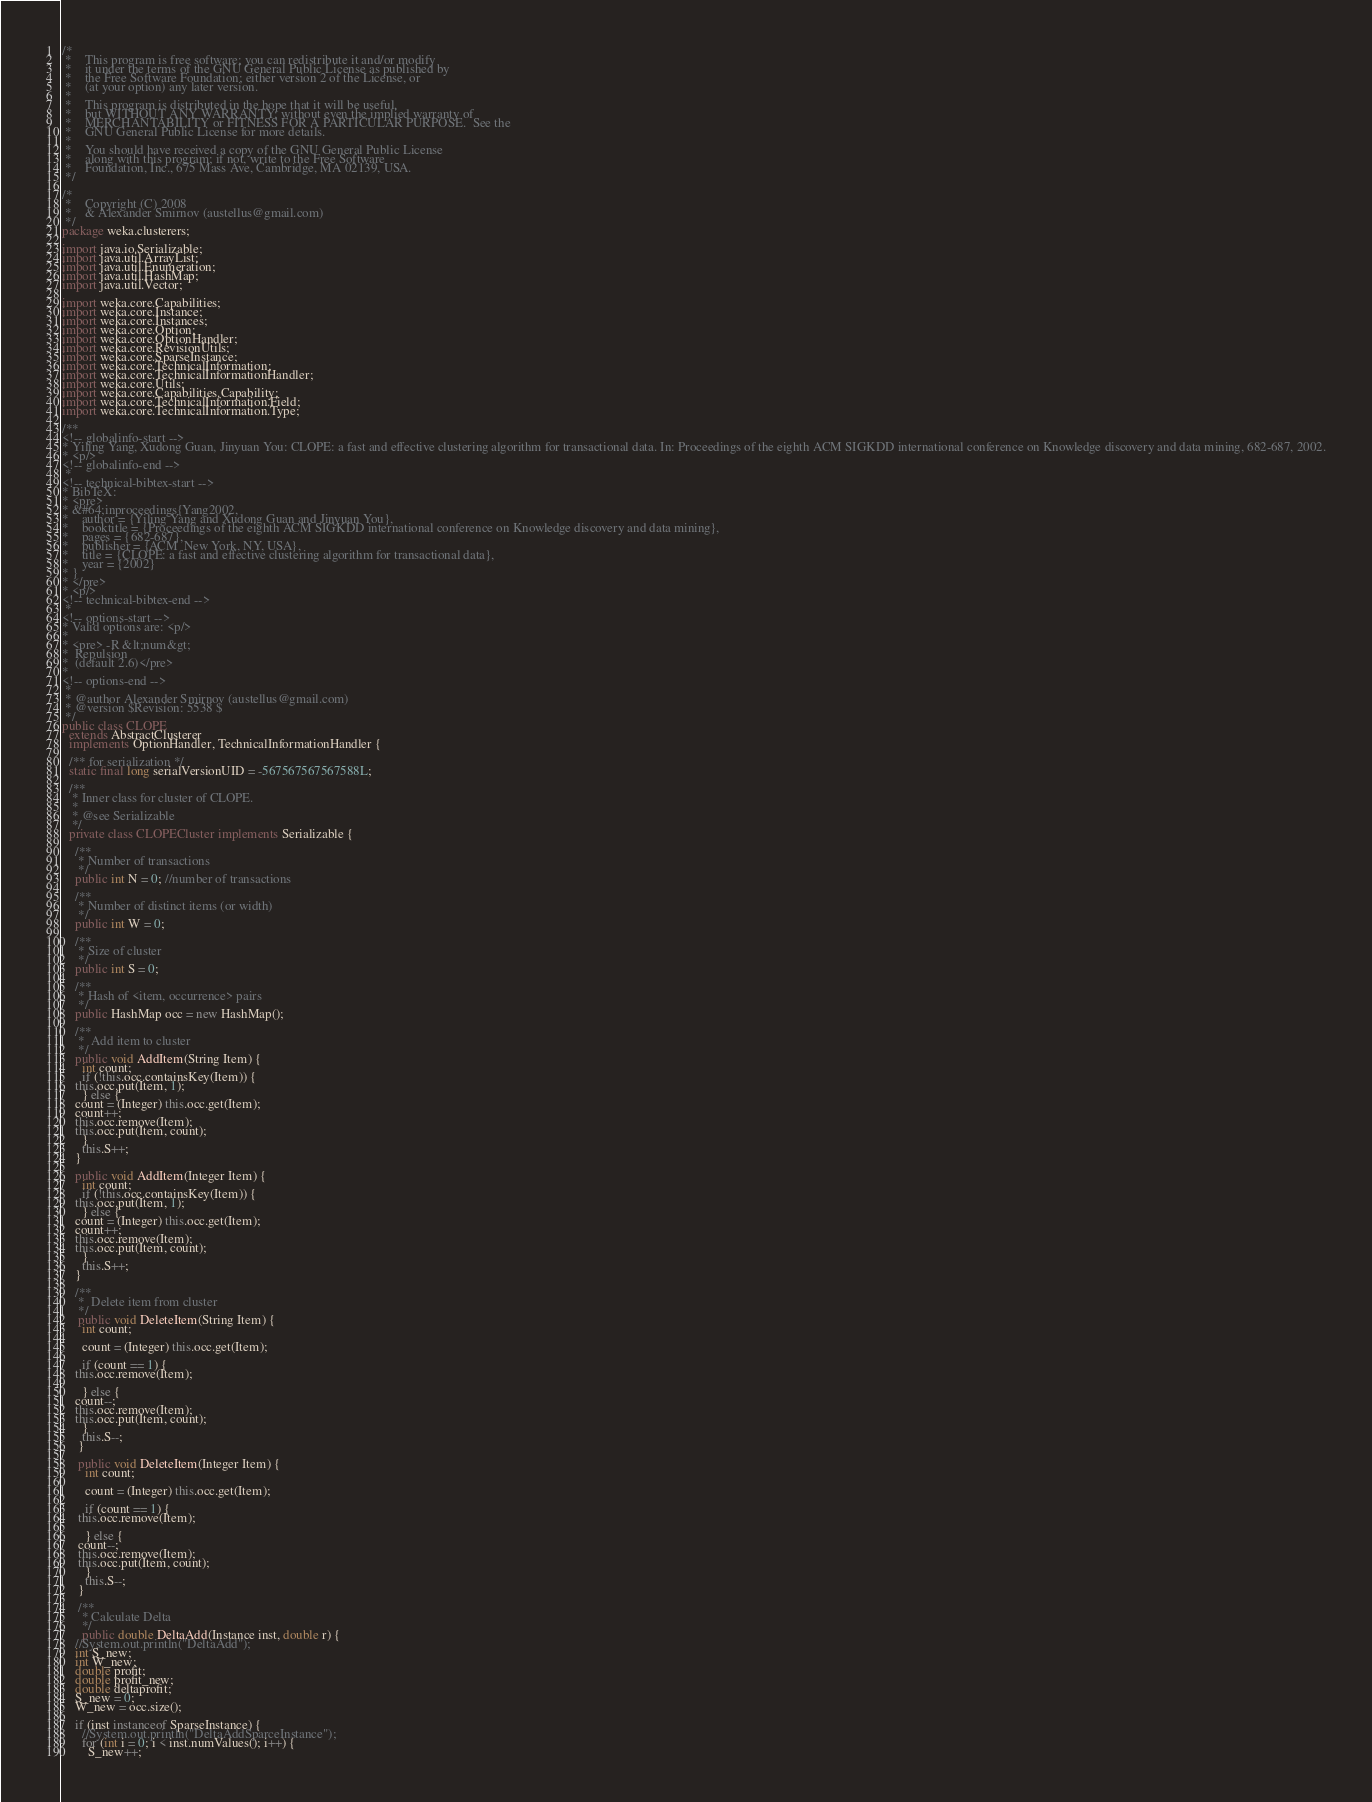<code> <loc_0><loc_0><loc_500><loc_500><_Java_>/*
 *    This program is free software; you can redistribute it and/or modify
 *    it under the terms of the GNU General Public License as published by
 *    the Free Software Foundation; either version 2 of the License, or
 *    (at your option) any later version.
 *
 *    This program is distributed in the hope that it will be useful,
 *    but WITHOUT ANY WARRANTY; without even the implied warranty of
 *    MERCHANTABILITY or FITNESS FOR A PARTICULAR PURPOSE.  See the
 *    GNU General Public License for more details.
 *
 *    You should have received a copy of the GNU General Public License
 *    along with this program; if not, write to the Free Software
 *    Foundation, Inc., 675 Mass Ave, Cambridge, MA 02139, USA.
 */

/*
 *    Copyright (C) 2008
 *    & Alexander Smirnov (austellus@gmail.com)
 */
package weka.clusterers;

import java.io.Serializable;
import java.util.ArrayList;
import java.util.Enumeration;
import java.util.HashMap;
import java.util.Vector;

import weka.core.Capabilities;
import weka.core.Instance;
import weka.core.Instances;
import weka.core.Option;
import weka.core.OptionHandler;
import weka.core.RevisionUtils;
import weka.core.SparseInstance;
import weka.core.TechnicalInformation;
import weka.core.TechnicalInformationHandler;
import weka.core.Utils;
import weka.core.Capabilities.Capability;
import weka.core.TechnicalInformation.Field;
import weka.core.TechnicalInformation.Type;

/**
<!-- globalinfo-start -->
* Yiling Yang, Xudong Guan, Jinyuan You: CLOPE: a fast and effective clustering algorithm for transactional data. In: Proceedings of the eighth ACM SIGKDD international conference on Knowledge discovery and data mining, 682-687, 2002.
* <p/>
<!-- globalinfo-end -->
 *
<!-- technical-bibtex-start -->
* BibTeX:
* <pre>
* &#64;inproceedings{Yang2002,
*    author = {Yiling Yang and Xudong Guan and Jinyuan You},
*    booktitle = {Proceedings of the eighth ACM SIGKDD international conference on Knowledge discovery and data mining},
*    pages = {682-687},
*    publisher = {ACM  New York, NY, USA},
*    title = {CLOPE: a fast and effective clustering algorithm for transactional data},
*    year = {2002}
* }
* </pre>
* <p/>
<!-- technical-bibtex-end -->
 *
<!-- options-start -->
* Valid options are: <p/>
* 
* <pre> -R &lt;num&gt;
*  Repulsion
*  (default 2.6)</pre>
* 
<!-- options-end -->
 *
 * @author Alexander Smirnov (austellus@gmail.com)
 * @version $Revision: 5538 $
 */
public class CLOPE
  extends AbstractClusterer
  implements OptionHandler, TechnicalInformationHandler {

  /** for serialization */
  static final long serialVersionUID = -567567567567588L;

  /**
   * Inner class for cluster of CLOPE.
   *
   * @see Serializable
   */
  private class CLOPECluster implements Serializable {

    /**
     * Number of transactions
     */
    public int N = 0; //number of transactions
    
    /**
     * Number of distinct items (or width)
     */
    public int W = 0;
    
    /**
     * Size of cluster
     */
    public int S = 0;
    
    /**
     * Hash of <item, occurrence> pairs
     */
    public HashMap occ = new HashMap();

    /**
     *  Add item to cluster
     */
    public void AddItem(String Item) {
      int count;
      if (!this.occ.containsKey(Item)) {
	this.occ.put(Item, 1);
      } else {
	count = (Integer) this.occ.get(Item);
	count++;
	this.occ.remove(Item);
	this.occ.put(Item, count);
      }
      this.S++;
    }

    public void AddItem(Integer Item) {
      int count;
      if (!this.occ.containsKey(Item)) {
	this.occ.put(Item, 1);
      } else {
	count = (Integer) this.occ.get(Item);
	count++;
	this.occ.remove(Item);
	this.occ.put(Item, count);
      }
      this.S++;
    }

    /**
     *  Delete item from cluster
     */
     public void DeleteItem(String Item) {
      int count;

      count = (Integer) this.occ.get(Item);

      if (count == 1) {
	this.occ.remove(Item);

      } else {
	count--;
	this.occ.remove(Item);
	this.occ.put(Item, count);
      }
      this.S--;
     }

     public void DeleteItem(Integer Item) {
       int count;

       count = (Integer) this.occ.get(Item);

       if (count == 1) {
	 this.occ.remove(Item);

       } else {
	 count--;
	 this.occ.remove(Item);
	 this.occ.put(Item, count);
       }
       this.S--;
     }

     /**
      * Calculate Delta
      */
      public double DeltaAdd(Instance inst, double r) {
	//System.out.println("DeltaAdd");
	int S_new;
	int W_new;
	double profit;
	double profit_new;
	double deltaprofit;
	S_new = 0;
	W_new = occ.size();

	if (inst instanceof SparseInstance) {
	  //System.out.println("DeltaAddSparceInstance");
	  for (int i = 0; i < inst.numValues(); i++) {
	    S_new++;
</code> 